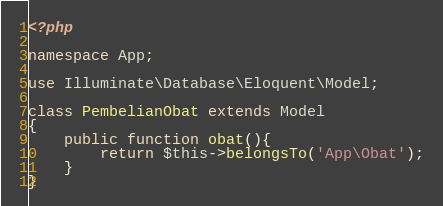<code> <loc_0><loc_0><loc_500><loc_500><_PHP_><?php

namespace App;

use Illuminate\Database\Eloquent\Model;

class PembelianObat extends Model
{
	public function obat(){
		return $this->belongsTo('App\Obat');
	}
}
</code> 